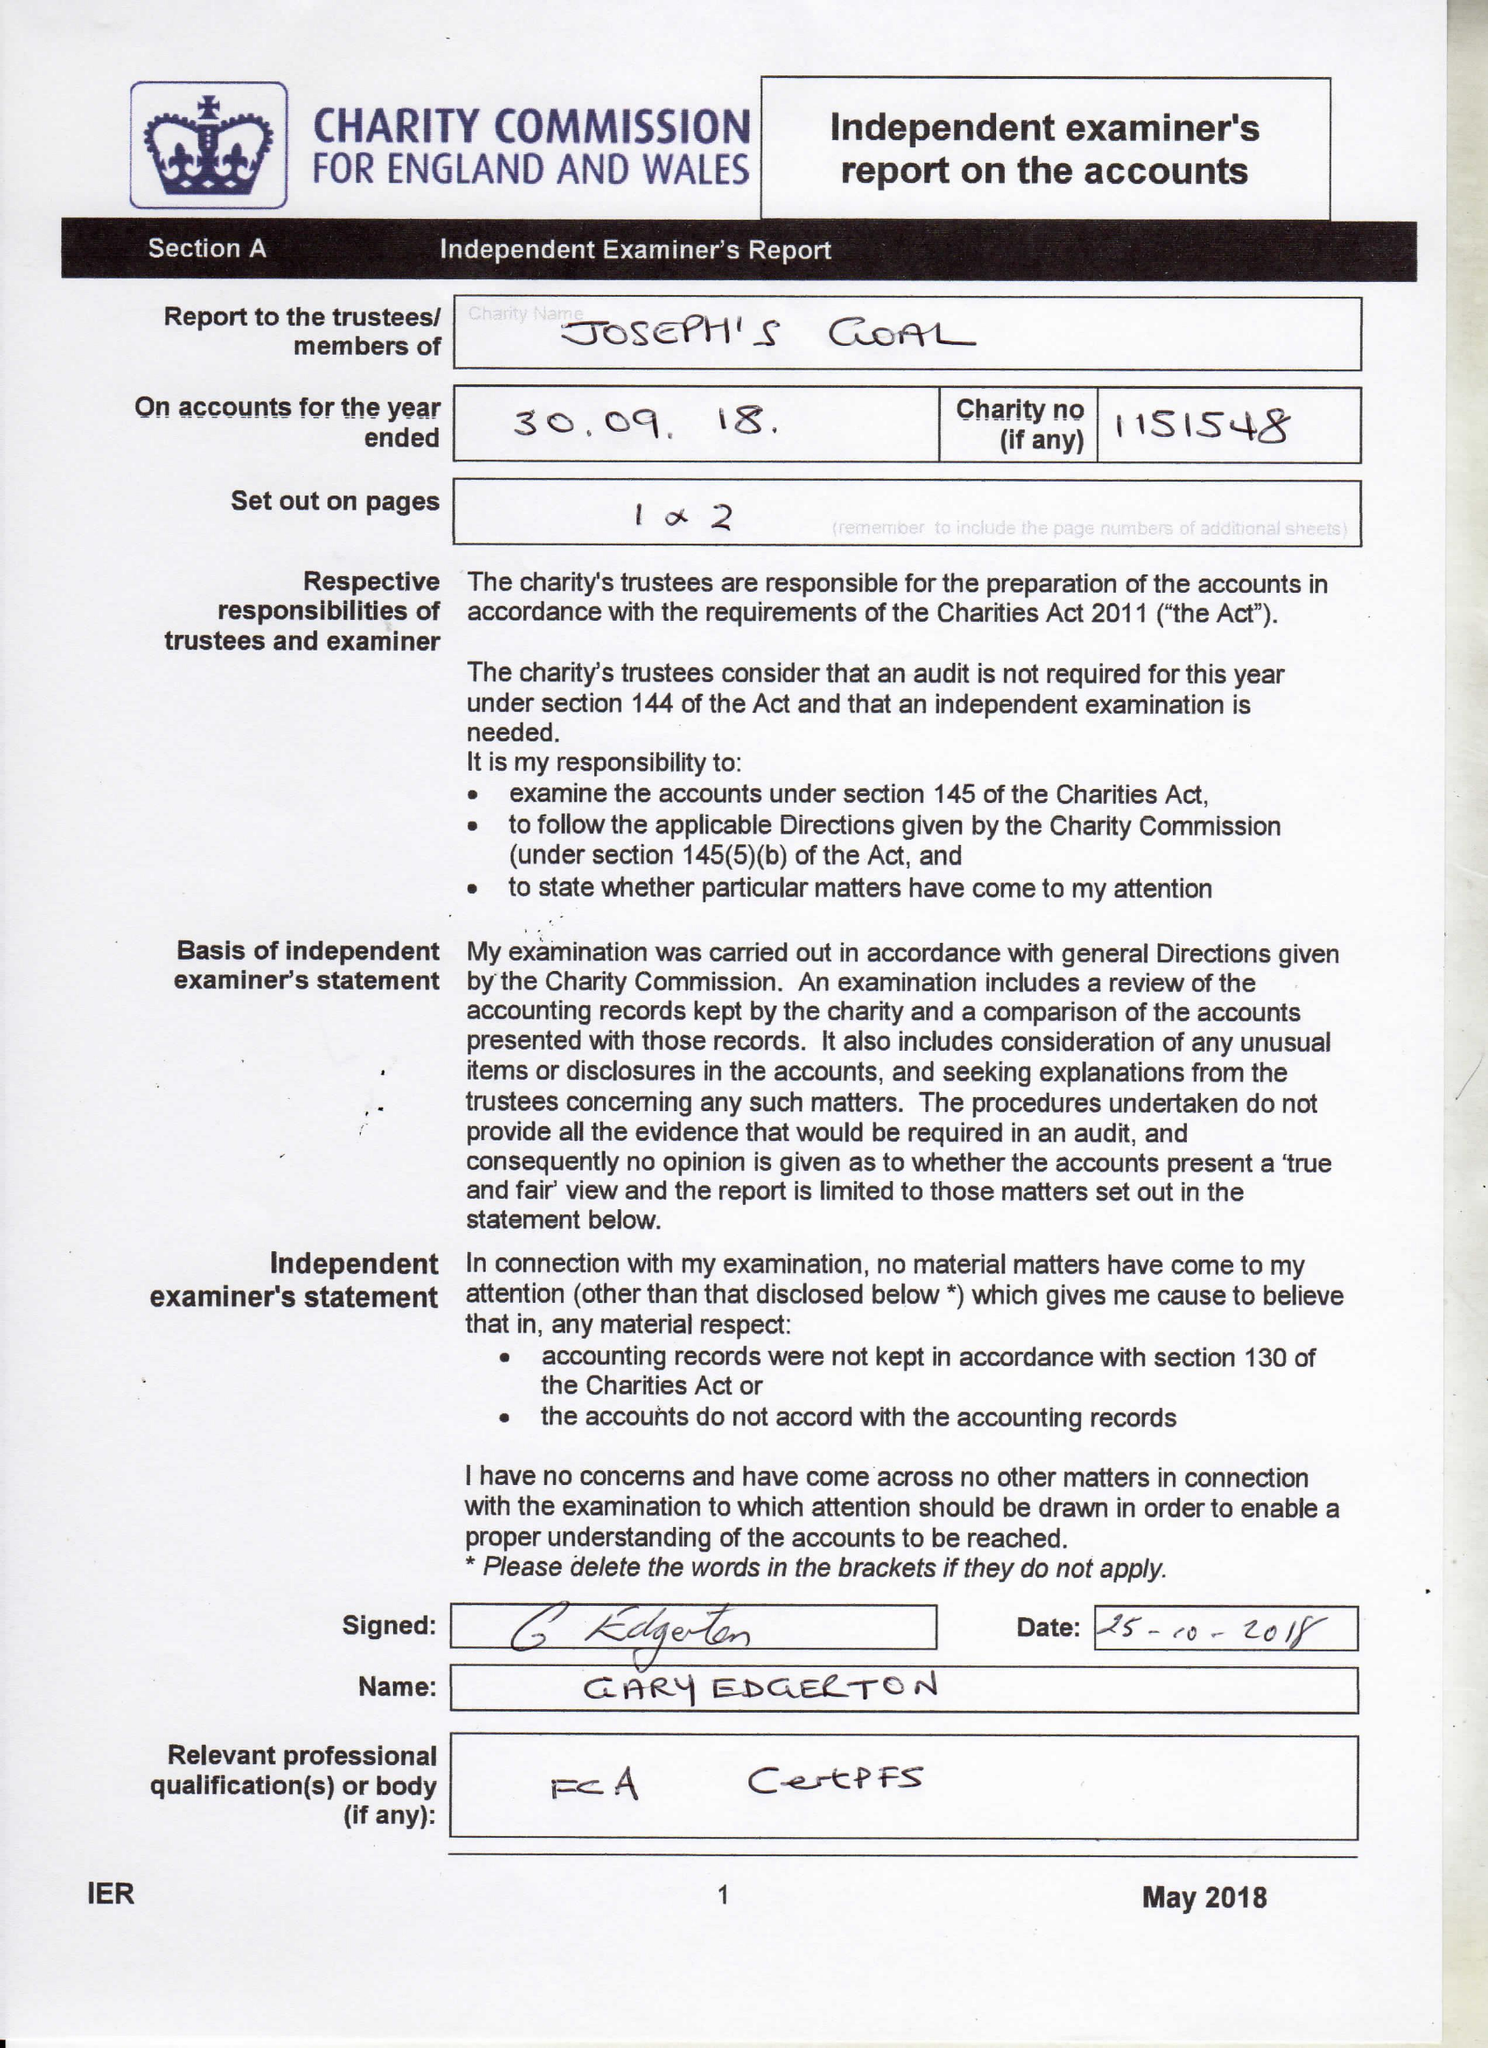What is the value for the income_annually_in_british_pounds?
Answer the question using a single word or phrase. 207540.00 